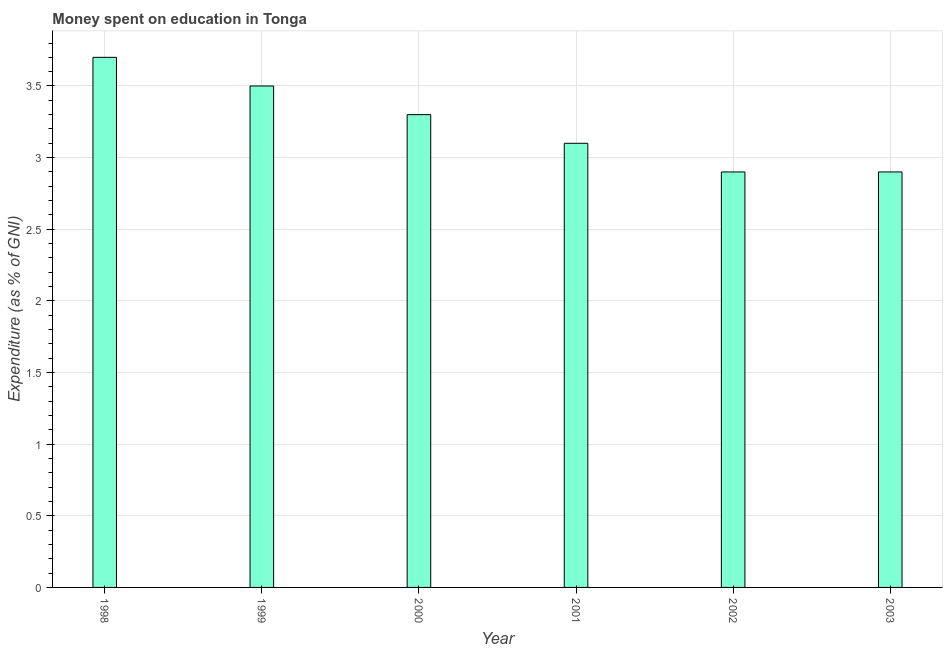Does the graph contain any zero values?
Ensure brevity in your answer.  No. Does the graph contain grids?
Your answer should be very brief. Yes. What is the title of the graph?
Offer a very short reply. Money spent on education in Tonga. What is the label or title of the Y-axis?
Provide a short and direct response. Expenditure (as % of GNI). What is the expenditure on education in 2001?
Offer a very short reply. 3.1. Across all years, what is the maximum expenditure on education?
Give a very brief answer. 3.7. Across all years, what is the minimum expenditure on education?
Ensure brevity in your answer.  2.9. In which year was the expenditure on education minimum?
Your response must be concise. 2002. What is the sum of the expenditure on education?
Your answer should be compact. 19.4. What is the difference between the expenditure on education in 1998 and 2002?
Offer a very short reply. 0.8. What is the average expenditure on education per year?
Your response must be concise. 3.23. What is the median expenditure on education?
Your answer should be compact. 3.2. What is the ratio of the expenditure on education in 2000 to that in 2001?
Provide a succinct answer. 1.06. Is the expenditure on education in 1999 less than that in 2001?
Ensure brevity in your answer.  No. Is the difference between the expenditure on education in 1998 and 2001 greater than the difference between any two years?
Provide a short and direct response. No. What is the difference between the highest and the second highest expenditure on education?
Your response must be concise. 0.2. Is the sum of the expenditure on education in 2001 and 2003 greater than the maximum expenditure on education across all years?
Ensure brevity in your answer.  Yes. What is the difference between two consecutive major ticks on the Y-axis?
Your answer should be compact. 0.5. Are the values on the major ticks of Y-axis written in scientific E-notation?
Offer a very short reply. No. What is the Expenditure (as % of GNI) in 1998?
Offer a very short reply. 3.7. What is the Expenditure (as % of GNI) in 1999?
Your answer should be compact. 3.5. What is the Expenditure (as % of GNI) of 2000?
Offer a terse response. 3.3. What is the Expenditure (as % of GNI) of 2001?
Offer a very short reply. 3.1. What is the Expenditure (as % of GNI) of 2002?
Your answer should be very brief. 2.9. What is the difference between the Expenditure (as % of GNI) in 1998 and 2000?
Your answer should be very brief. 0.4. What is the difference between the Expenditure (as % of GNI) in 1999 and 2002?
Your response must be concise. 0.6. What is the difference between the Expenditure (as % of GNI) in 2000 and 2001?
Make the answer very short. 0.2. What is the difference between the Expenditure (as % of GNI) in 2000 and 2003?
Provide a succinct answer. 0.4. What is the difference between the Expenditure (as % of GNI) in 2001 and 2002?
Provide a succinct answer. 0.2. What is the difference between the Expenditure (as % of GNI) in 2001 and 2003?
Provide a succinct answer. 0.2. What is the ratio of the Expenditure (as % of GNI) in 1998 to that in 1999?
Keep it short and to the point. 1.06. What is the ratio of the Expenditure (as % of GNI) in 1998 to that in 2000?
Your answer should be very brief. 1.12. What is the ratio of the Expenditure (as % of GNI) in 1998 to that in 2001?
Ensure brevity in your answer.  1.19. What is the ratio of the Expenditure (as % of GNI) in 1998 to that in 2002?
Provide a short and direct response. 1.28. What is the ratio of the Expenditure (as % of GNI) in 1998 to that in 2003?
Keep it short and to the point. 1.28. What is the ratio of the Expenditure (as % of GNI) in 1999 to that in 2000?
Ensure brevity in your answer.  1.06. What is the ratio of the Expenditure (as % of GNI) in 1999 to that in 2001?
Give a very brief answer. 1.13. What is the ratio of the Expenditure (as % of GNI) in 1999 to that in 2002?
Make the answer very short. 1.21. What is the ratio of the Expenditure (as % of GNI) in 1999 to that in 2003?
Ensure brevity in your answer.  1.21. What is the ratio of the Expenditure (as % of GNI) in 2000 to that in 2001?
Make the answer very short. 1.06. What is the ratio of the Expenditure (as % of GNI) in 2000 to that in 2002?
Provide a short and direct response. 1.14. What is the ratio of the Expenditure (as % of GNI) in 2000 to that in 2003?
Keep it short and to the point. 1.14. What is the ratio of the Expenditure (as % of GNI) in 2001 to that in 2002?
Provide a succinct answer. 1.07. What is the ratio of the Expenditure (as % of GNI) in 2001 to that in 2003?
Your response must be concise. 1.07. 